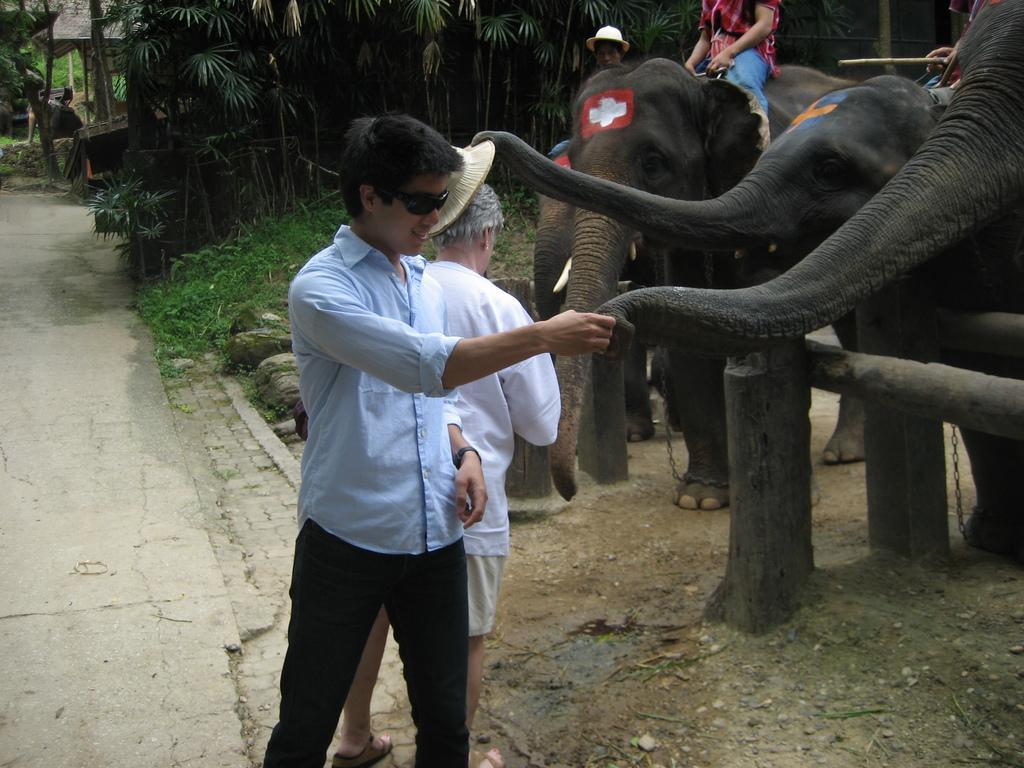How would you summarize this image in a sentence or two? In this picture there is a boy who is wearing goggles, shirt, watch and trouser. He is holding an elephant's trunk. Beside him there is an old man who is wearing white t-shirt, short and sleeper. On the right there are four elephants which are standing behind this wooden fencing. In the top right there is a man who is sitting on the elephant and holding the ropes. In the background i can see many trees, plants and grass. In the top left corner there is a man who is standing near to the hut. 